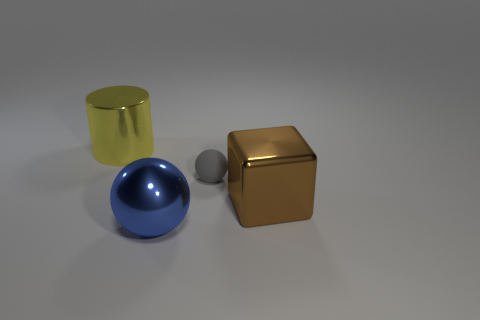Do the materials of the objects tell you what they might be used for? The glossy materials suggest that these are not utilitarian objects but could be decorative or used in visual presentations, possibly as part of a rendering study or a design concept. 